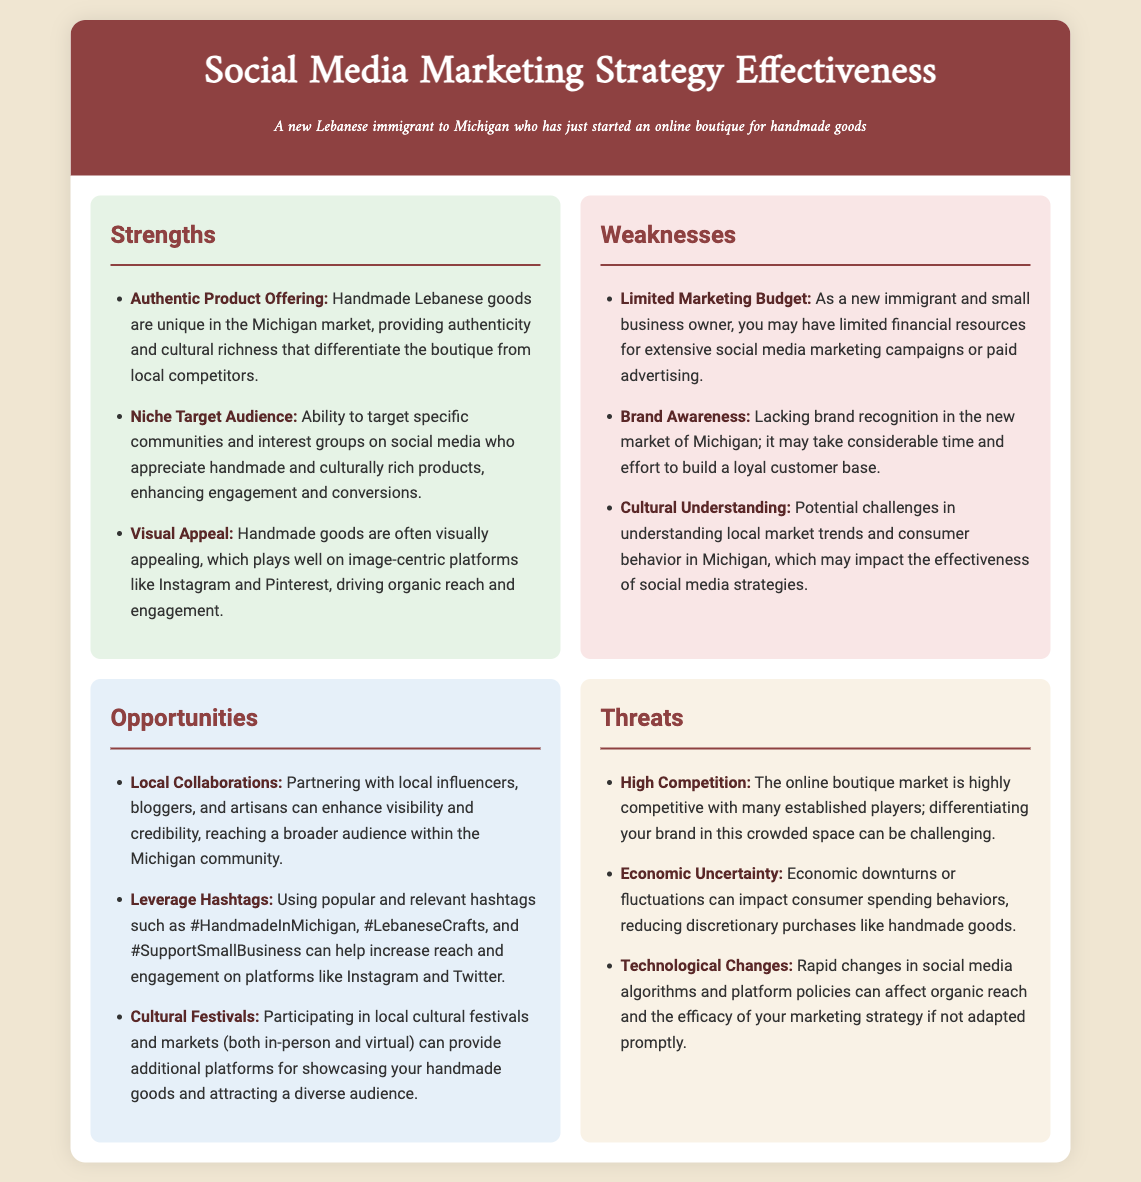What are the strengths of the social media marketing strategy? The strengths include authentic product offering, niche target audience, and visual appeal.
Answer: Authentic product offering, niche target audience, visual appeal What is one weakness mentioned in the document? The document lists specific weaknesses, including limited marketing budget, brand awareness, and cultural understanding.
Answer: Limited marketing budget How can local collaborations benefit the boutique? Collaborations can enhance visibility and credibility, reaching a broader audience within the Michigan community.
Answer: Enhance visibility and credibility What is a threat related to competition? The document describes a threat of high competition in the online boutique market, making differentiation challenging.
Answer: High competition What is the role of hashtags according to the opportunities? The use of hashtags can help increase reach and engagement on social media platforms.
Answer: Increase reach and engagement How many specific strengths are listed? There are three specific strengths mentioned in the document.
Answer: Three What is one example of a cultural event for opportunities? The document suggests participating in local cultural festivals and markets as a way to showcase products.
Answer: Cultural festivals What potential impact does economic uncertainty have? Economic uncertainty may reduce discretionary purchases like handmade goods.
Answer: Reduce discretionary purchases 